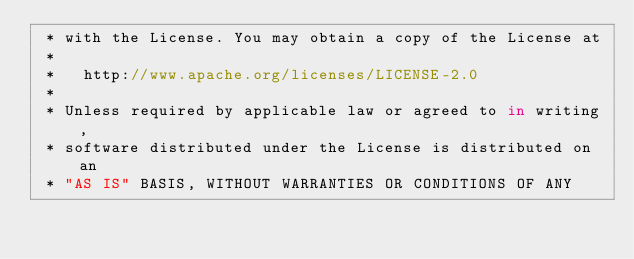<code> <loc_0><loc_0><loc_500><loc_500><_Haxe_> * with the License. You may obtain a copy of the License at
 *
 *   http://www.apache.org/licenses/LICENSE-2.0
 *
 * Unless required by applicable law or agreed to in writing,
 * software distributed under the License is distributed on an
 * "AS IS" BASIS, WITHOUT WARRANTIES OR CONDITIONS OF ANY</code> 